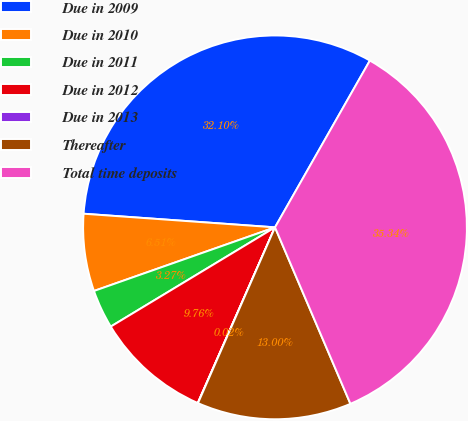Convert chart. <chart><loc_0><loc_0><loc_500><loc_500><pie_chart><fcel>Due in 2009<fcel>Due in 2010<fcel>Due in 2011<fcel>Due in 2012<fcel>Due in 2013<fcel>Thereafter<fcel>Total time deposits<nl><fcel>32.1%<fcel>6.51%<fcel>3.27%<fcel>9.76%<fcel>0.02%<fcel>13.0%<fcel>35.34%<nl></chart> 